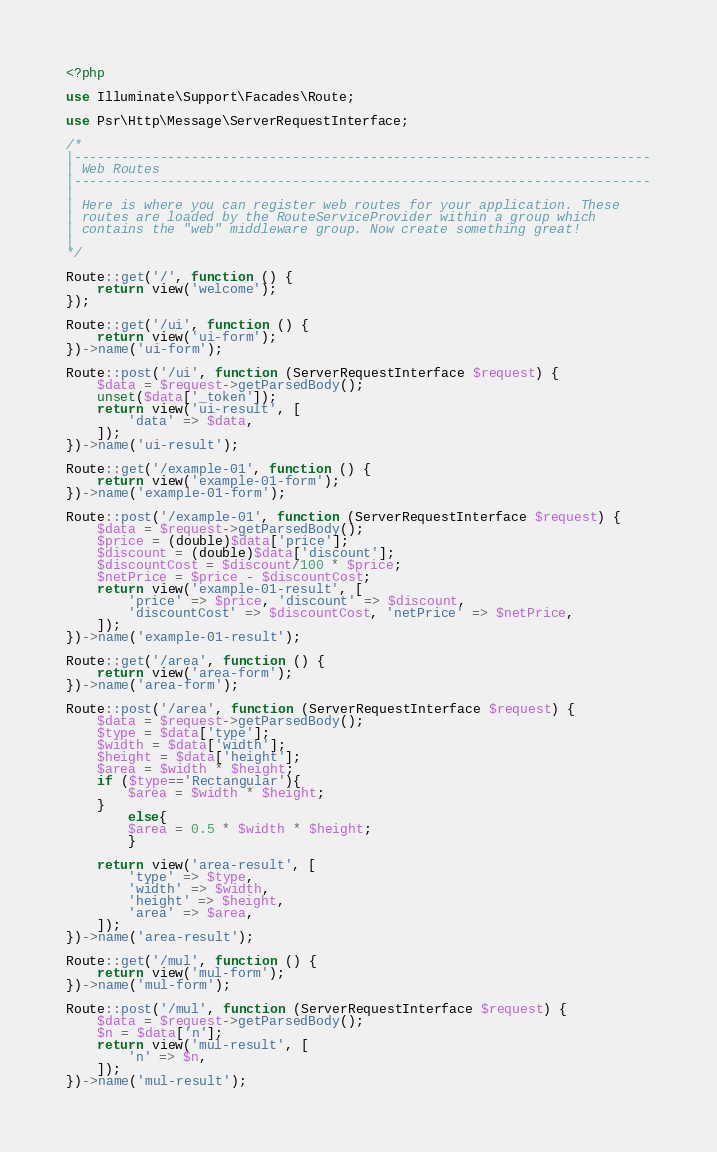<code> <loc_0><loc_0><loc_500><loc_500><_PHP_><?php

use Illuminate\Support\Facades\Route;

use Psr\Http\Message\ServerRequestInterface;

/*
|--------------------------------------------------------------------------
| Web Routes
|--------------------------------------------------------------------------
|
| Here is where you can register web routes for your application. These
| routes are loaded by the RouteServiceProvider within a group which
| contains the "web" middleware group. Now create something great!
|
*/

Route::get('/', function () {
    return view('welcome');
});

Route::get('/ui', function () {
    return view('ui-form');
})->name('ui-form');

Route::post('/ui', function (ServerRequestInterface $request) {
    $data = $request->getParsedBody();
    unset($data['_token']);
    return view('ui-result', [
        'data' => $data,
    ]);
})->name('ui-result');

Route::get('/example-01', function () {
    return view('example-01-form');
})->name('example-01-form');

Route::post('/example-01', function (ServerRequestInterface $request) {
    $data = $request->getParsedBody();
    $price = (double)$data['price'];
    $discount = (double)$data['discount'];
    $discountCost = $discount/100 * $price;
    $netPrice = $price - $discountCost;
    return view('example-01-result', [
        'price' => $price, 'discount' => $discount,
        'discountCost' => $discountCost, 'netPrice' => $netPrice,
    ]);
})->name('example-01-result');

Route::get('/area', function () {
    return view('area-form');
})->name('area-form');

Route::post('/area', function (ServerRequestInterface $request) {
    $data = $request->getParsedBody();
    $type = $data['type'];
    $width = $data['width'];
    $height = $data['height'];
    $area = $width * $height;
    if ($type=='Rectangular'){
        $area = $width * $height;
    }
        else{
        $area = 0.5 * $width * $height;  
        }
    
    return view('area-result', [
        'type' => $type, 
        'width' => $width,
        'height' => $height, 
        'area' => $area,
    ]);
})->name('area-result');

Route::get('/mul', function () {
    return view('mul-form');
})->name('mul-form');

Route::post('/mul', function (ServerRequestInterface $request) {
    $data = $request->getParsedBody();
	$n = $data['n'];
    return view('mul-result', [
        'n' => $n,
    ]);
})->name('mul-result');
</code> 